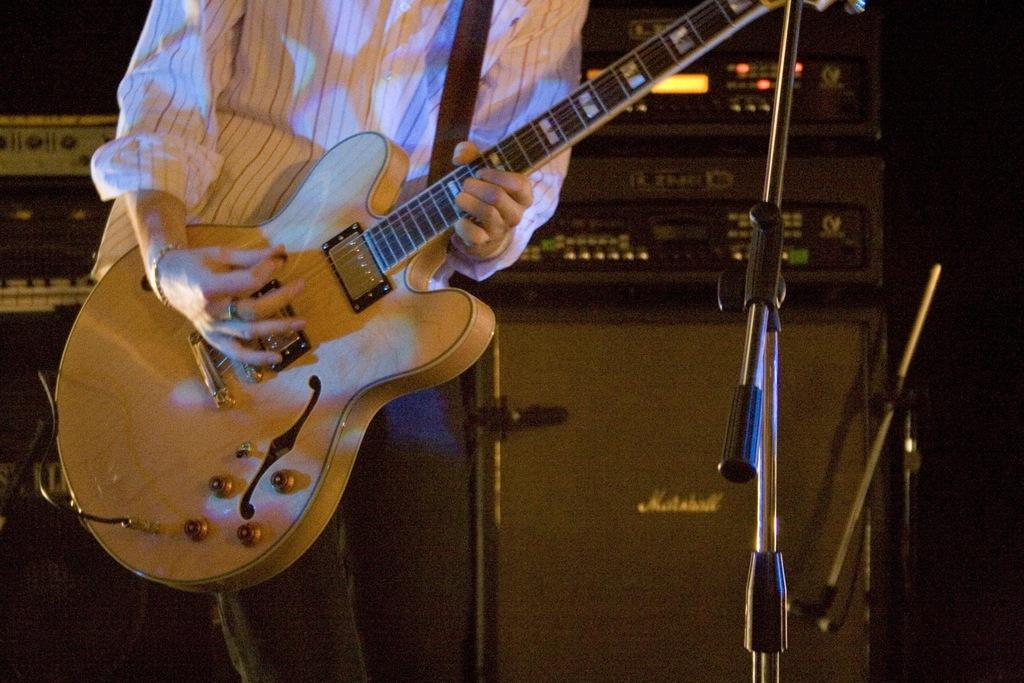What type of clothing is the person wearing in the image? The person is wearing a shirt and pants in the image. What is the person holding in the image? The person is holding a guitar in the image. What is the person doing with the guitar? The person is playing the guitar in the image. What can be seen in the background of the image? There is equipment visible in the background. What else is present in the image besides the person and the guitar? There are mic stands in the image. Is the person's father playing the guitar with them in the image? There is no information about the person's father in the image, so we cannot determine if they are present or playing the guitar. Can you see any snakes in the image? There are no snakes present in the image. 